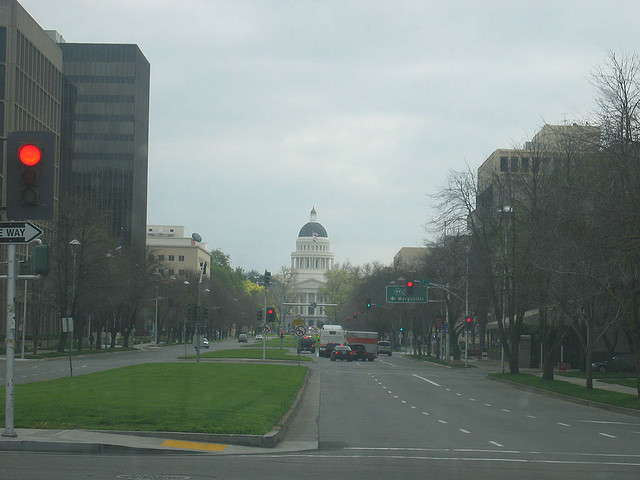Read all the text in this image. WAY 